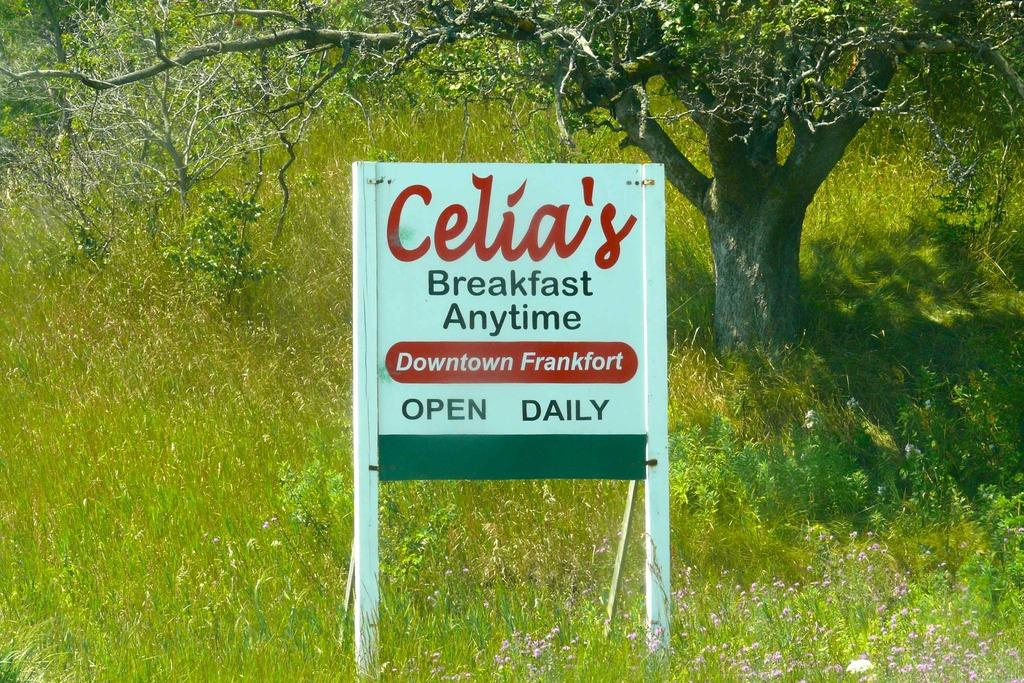What type of living organisms can be seen in the image? Plants and trees are visible in the image. Can you describe the main object in the middle of the image? There is a board in the middle of the image. How many hours of sleep can be seen in the image? There is no reference to sleep or any sleeping organisms in the image. What type of note is attached to the board in the image? There is no note present on the board in the image. 